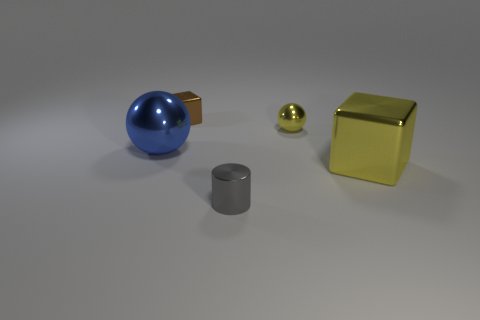What shape is the large blue thing that is the same material as the small yellow thing?
Your answer should be compact. Sphere. There is a small metallic thing that is the same color as the big metal block; what shape is it?
Your response must be concise. Sphere. There is a metallic object that is the same color as the big shiny block; what is its size?
Provide a short and direct response. Small. Does the small metal block have the same color as the small metallic sphere?
Offer a very short reply. No. There is a big object to the right of the shiny object that is left of the small brown block; is there a big cube that is behind it?
Offer a very short reply. No. How many blue balls are the same size as the gray metal cylinder?
Provide a short and direct response. 0. There is a block that is to the left of the small gray cylinder; is its size the same as the shiny sphere that is left of the small metallic sphere?
Your answer should be very brief. No. The object that is both behind the big yellow cube and in front of the small shiny sphere has what shape?
Offer a terse response. Sphere. Are there any rubber objects of the same color as the large sphere?
Offer a very short reply. No. Are any big blue blocks visible?
Offer a terse response. No. 